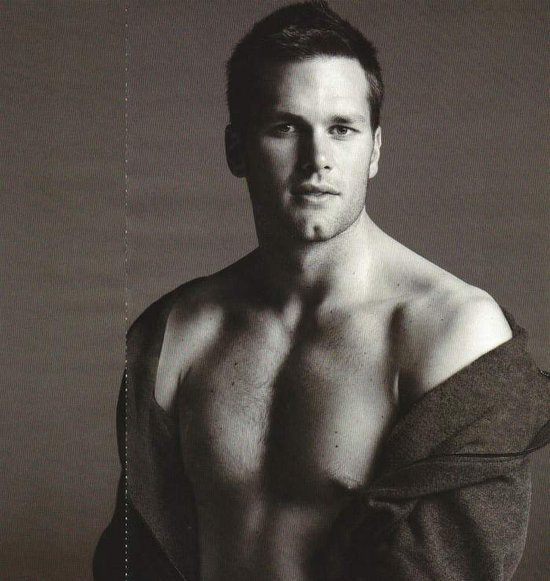Discuss the choice of monochrome for this photograph. How does it affect the viewer's perception? The monochrome palette of this photograph strips away the distractions of color, focusing the viewer's attention on the textures, contrasts, and the play of light and shadow. This choice emphasizes the tonal subtleties and the muscular definition of the subject, conveying a timeless and classic aesthetic. Monochrome often invokes a sense of nostalgia and evokes stronger emotional responses, making the image more striking and memorable. 